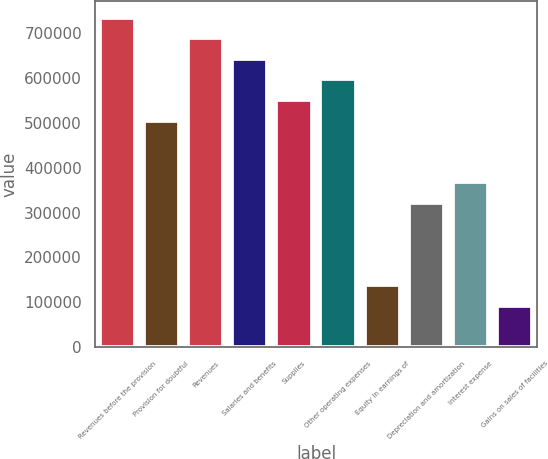Convert chart to OTSL. <chart><loc_0><loc_0><loc_500><loc_500><bar_chart><fcel>Revenues before the provision<fcel>Provision for doubtful<fcel>Revenues<fcel>Salaries and benefits<fcel>Supplies<fcel>Other operating expenses<fcel>Equity in earnings of<fcel>Depreciation and amortization<fcel>Interest expense<fcel>Gains on sales of facilities<nl><fcel>735043<fcel>505343<fcel>689103<fcel>643163<fcel>551283<fcel>597223<fcel>137823<fcel>321583<fcel>367523<fcel>91883.4<nl></chart> 